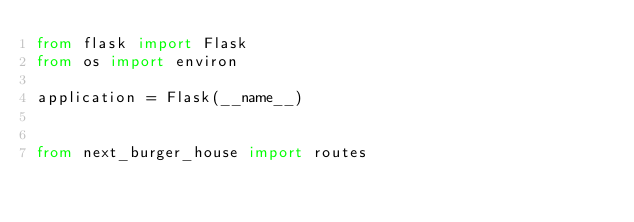Convert code to text. <code><loc_0><loc_0><loc_500><loc_500><_Python_>from flask import Flask
from os import environ

application = Flask(__name__)


from next_burger_house import routes</code> 